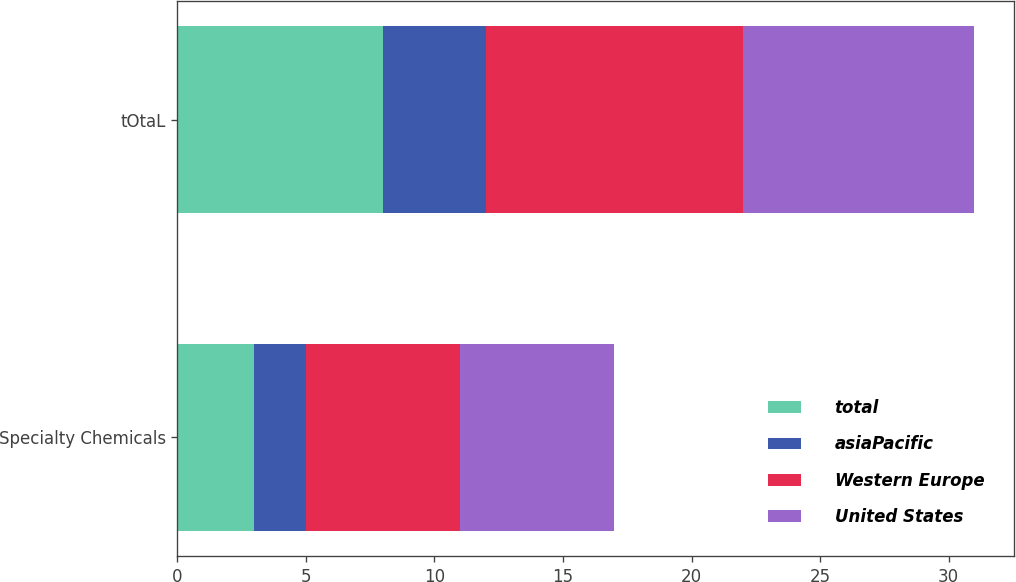<chart> <loc_0><loc_0><loc_500><loc_500><stacked_bar_chart><ecel><fcel>Specialty Chemicals<fcel>tOtaL<nl><fcel>total<fcel>3<fcel>8<nl><fcel>asiaPacific<fcel>2<fcel>4<nl><fcel>Western Europe<fcel>6<fcel>10<nl><fcel>United States<fcel>6<fcel>9<nl></chart> 